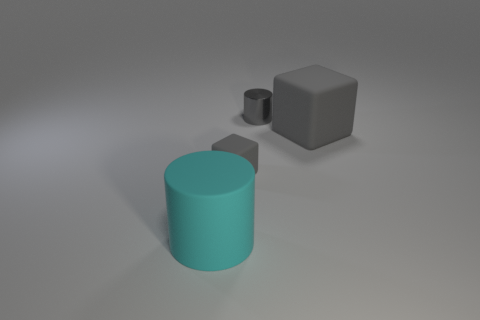What number of other things are there of the same color as the small cylinder?
Provide a short and direct response. 2. Are there any other things that have the same material as the gray cylinder?
Keep it short and to the point. No. There is a rubber cube that is the same size as the rubber cylinder; what color is it?
Your response must be concise. Gray. Are the gray thing that is right of the tiny metallic thing and the gray cylinder made of the same material?
Make the answer very short. No. There is a gray matte cube in front of the gray rubber thing that is right of the gray cylinder; are there any gray blocks that are on the right side of it?
Your response must be concise. Yes. Is the shape of the large object that is behind the large cyan thing the same as  the big cyan matte thing?
Offer a terse response. No. The gray rubber object behind the tiny rubber cube in front of the large gray thing is what shape?
Offer a terse response. Cube. There is a cylinder that is to the right of the matte block that is in front of the block that is to the right of the small gray metal object; how big is it?
Give a very brief answer. Small. What color is the metal object that is the same shape as the cyan rubber thing?
Offer a very short reply. Gray. There is a cylinder to the right of the large cyan rubber object; what is its material?
Your answer should be very brief. Metal. 